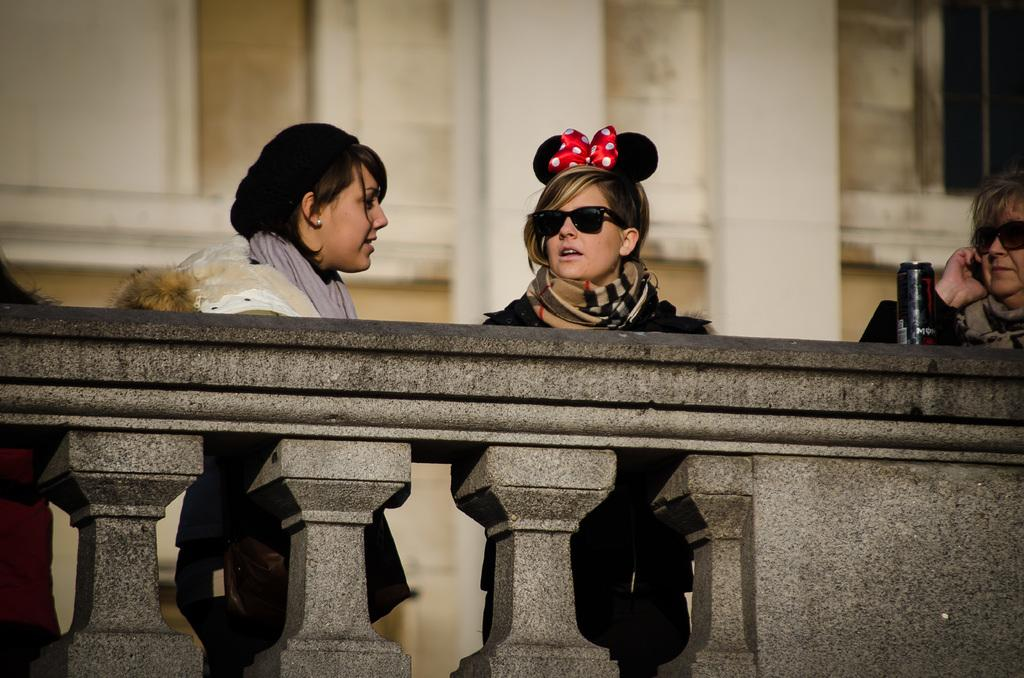What are the people in the image doing? The people in the image are standing near a wall. What can be seen on the wall? There is a tin on the wall. What can be seen in the distance behind the people? There is a building visible in the background of the image. How many chickens are visible in the image? There are no chickens present in the image. What type of request is being made by the people in the image? There is no indication of a request being made in the image. 